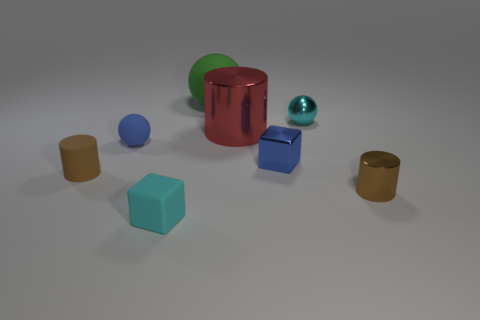Is the color of the small rubber sphere the same as the tiny metal cube?
Your answer should be very brief. Yes. What is the material of the small block that is the same color as the shiny ball?
Offer a terse response. Rubber. There is a cyan object that is behind the brown metallic thing; is it the same size as the green rubber sphere?
Make the answer very short. No. How many other objects are there of the same size as the matte cube?
Your response must be concise. 5. There is another cyan object that is the same shape as the large rubber thing; what is its material?
Ensure brevity in your answer.  Metal. Are there more tiny objects that are in front of the tiny matte cylinder than big green blocks?
Make the answer very short. Yes. Is there anything else that is the same color as the tiny metal cube?
Your response must be concise. Yes. The tiny brown object that is the same material as the green ball is what shape?
Keep it short and to the point. Cylinder. Do the cyan object in front of the tiny cyan ball and the big green sphere have the same material?
Make the answer very short. Yes. The small object that is the same color as the tiny matte cylinder is what shape?
Your response must be concise. Cylinder. 